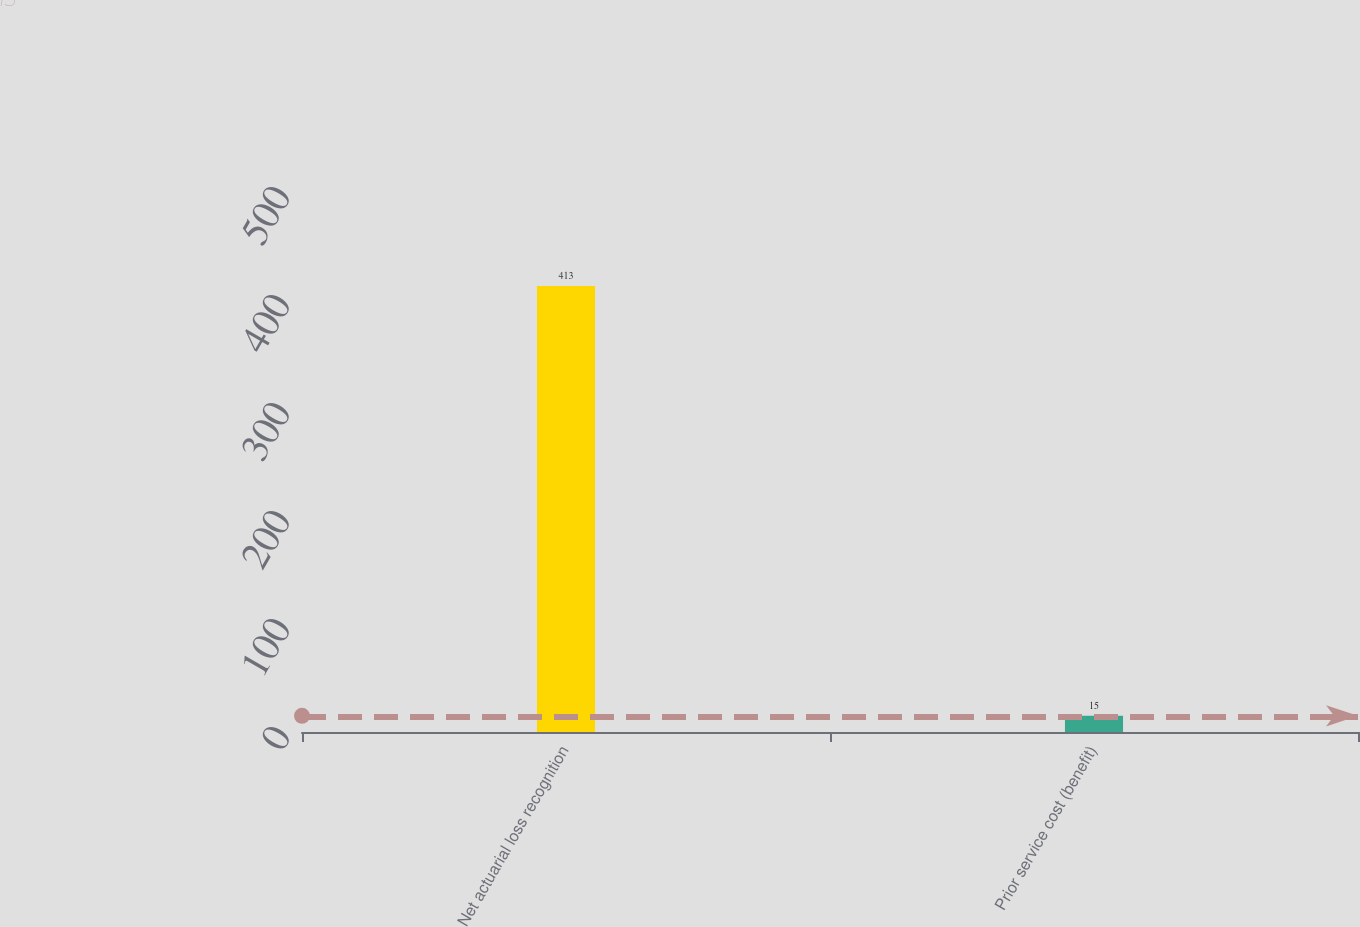Convert chart. <chart><loc_0><loc_0><loc_500><loc_500><bar_chart><fcel>Net actuarial loss recognition<fcel>Prior service cost (benefit)<nl><fcel>413<fcel>15<nl></chart> 